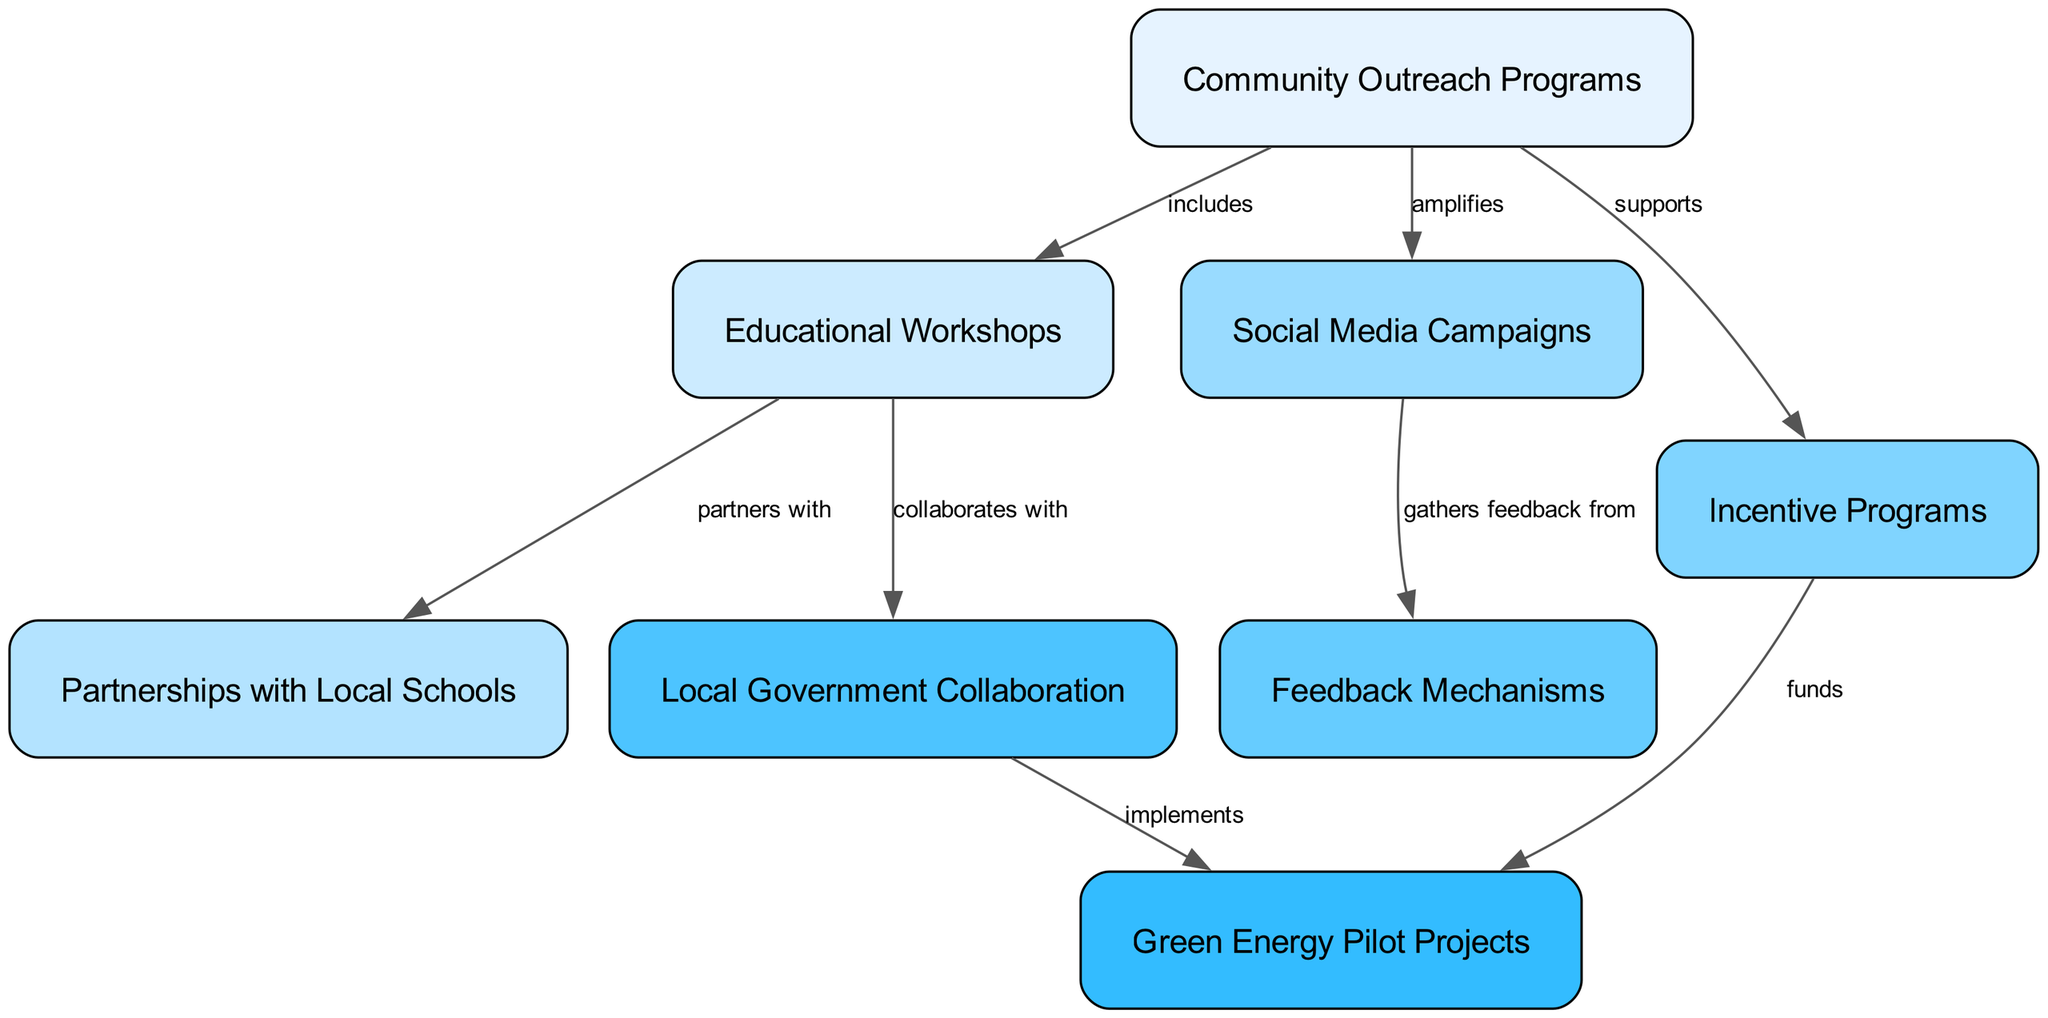What is the total number of nodes in the diagram? To find the total number of nodes, I count the number of distinct items listed under the "nodes" section in the data. There are 8 nodes total.
Answer: 8 Which node amplifies Community Outreach Programs? By examining the edges section, I identify the relationship labeled "amplifies" connected to "Community Outreach Programs," which points to "Social Media Campaigns."
Answer: Social Media Campaigns How many edges are present in the diagram? I count the relationships listed under the "edges" section. There are 8 edges, reflecting different connections between the nodes.
Answer: 8 What does Educational Workshops partner with? Looking at the edge labeled "partners with," I trace from "Educational Workshops" to its connected node, which is "Partnerships with Local Schools."
Answer: Partnerships with Local Schools Which node funds Green Energy Pilot Projects? Checking the edge labeled "funds," I find it connects "Incentive Programs" to "Green Energy Pilot Projects."
Answer: Incentive Programs What role does Local Government Collaboration have in the diagram? I see that "Local Government Collaboration" has an edge leading to "Green Energy Pilot Projects," labeled "implements." This indicates its role in implementation.
Answer: implements Which program supports the Incentive Programs in the diagram? I can see a directed edge from "Community Outreach Programs" to "Incentive Programs," labeled "supports," highlighting its supportive role.
Answer: Community Outreach Programs Which two nodes collaboratively work together according to the diagram? Observing the edges, the relationship labeled "collaborates with" shows that "Educational Workshops" collaborates with "Local Government Collaboration."
Answer: Local Government Collaboration How many nodes are directly connected to Community Outreach Programs? I check the outgoing edges from "Community Outreach Programs" and see three edges leading to "Educational Workshops," "Social Media Campaigns," and "Incentive Programs."
Answer: 3 